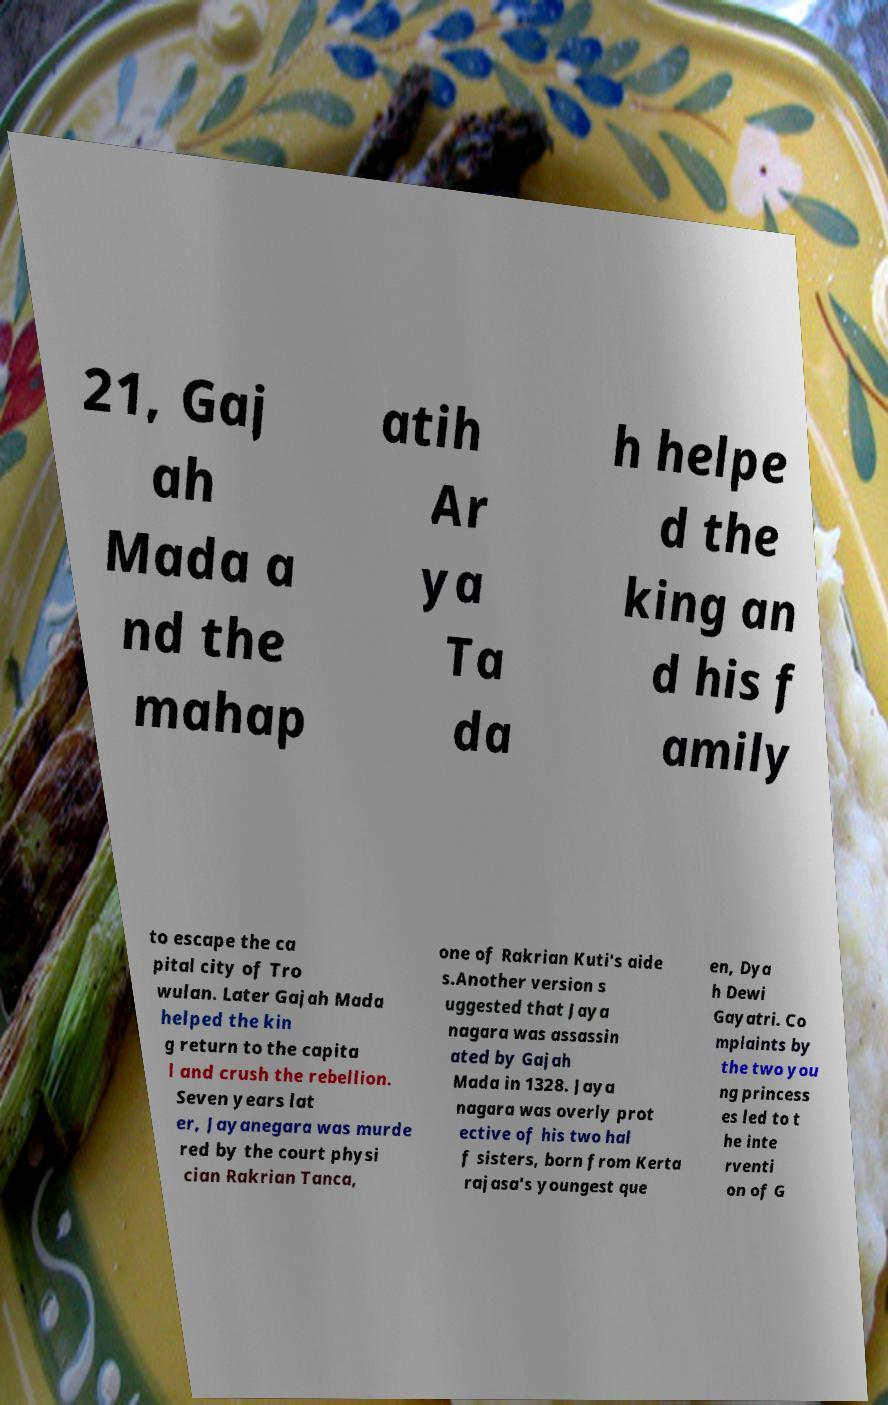There's text embedded in this image that I need extracted. Can you transcribe it verbatim? 21, Gaj ah Mada a nd the mahap atih Ar ya Ta da h helpe d the king an d his f amily to escape the ca pital city of Tro wulan. Later Gajah Mada helped the kin g return to the capita l and crush the rebellion. Seven years lat er, Jayanegara was murde red by the court physi cian Rakrian Tanca, one of Rakrian Kuti's aide s.Another version s uggested that Jaya nagara was assassin ated by Gajah Mada in 1328. Jaya nagara was overly prot ective of his two hal f sisters, born from Kerta rajasa's youngest que en, Dya h Dewi Gayatri. Co mplaints by the two you ng princess es led to t he inte rventi on of G 